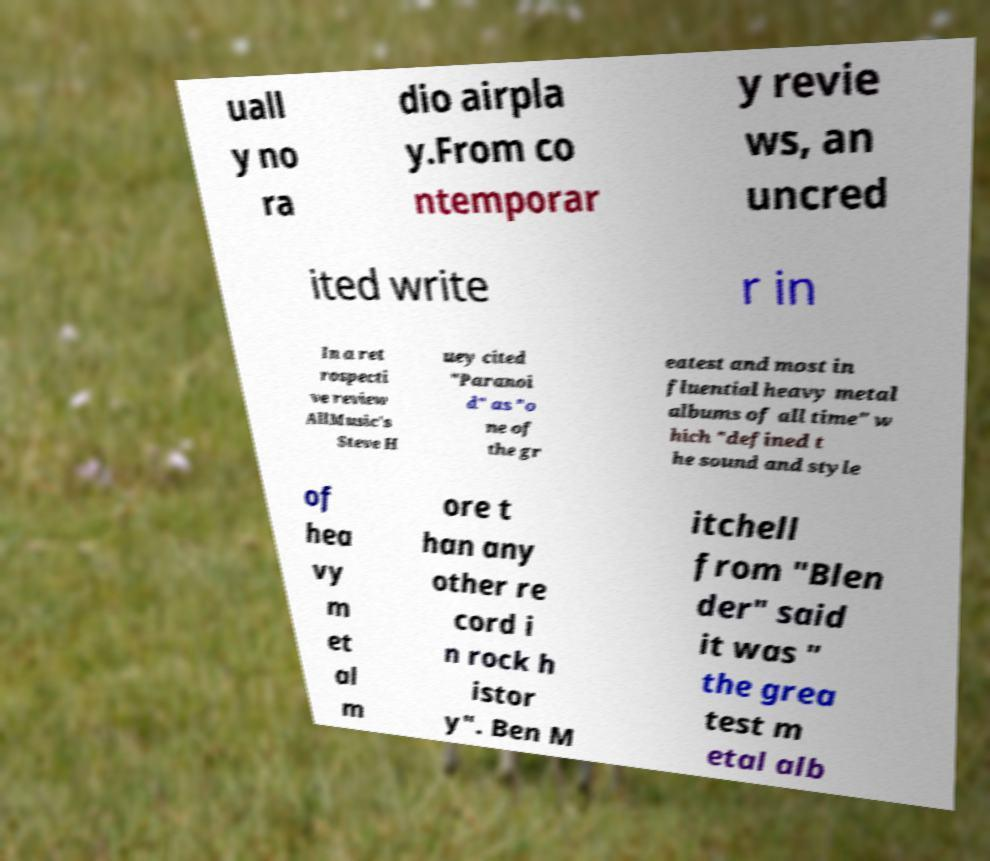Can you read and provide the text displayed in the image?This photo seems to have some interesting text. Can you extract and type it out for me? uall y no ra dio airpla y.From co ntemporar y revie ws, an uncred ited write r in In a ret rospecti ve review AllMusic's Steve H uey cited "Paranoi d" as "o ne of the gr eatest and most in fluential heavy metal albums of all time" w hich "defined t he sound and style of hea vy m et al m ore t han any other re cord i n rock h istor y". Ben M itchell from "Blen der" said it was " the grea test m etal alb 